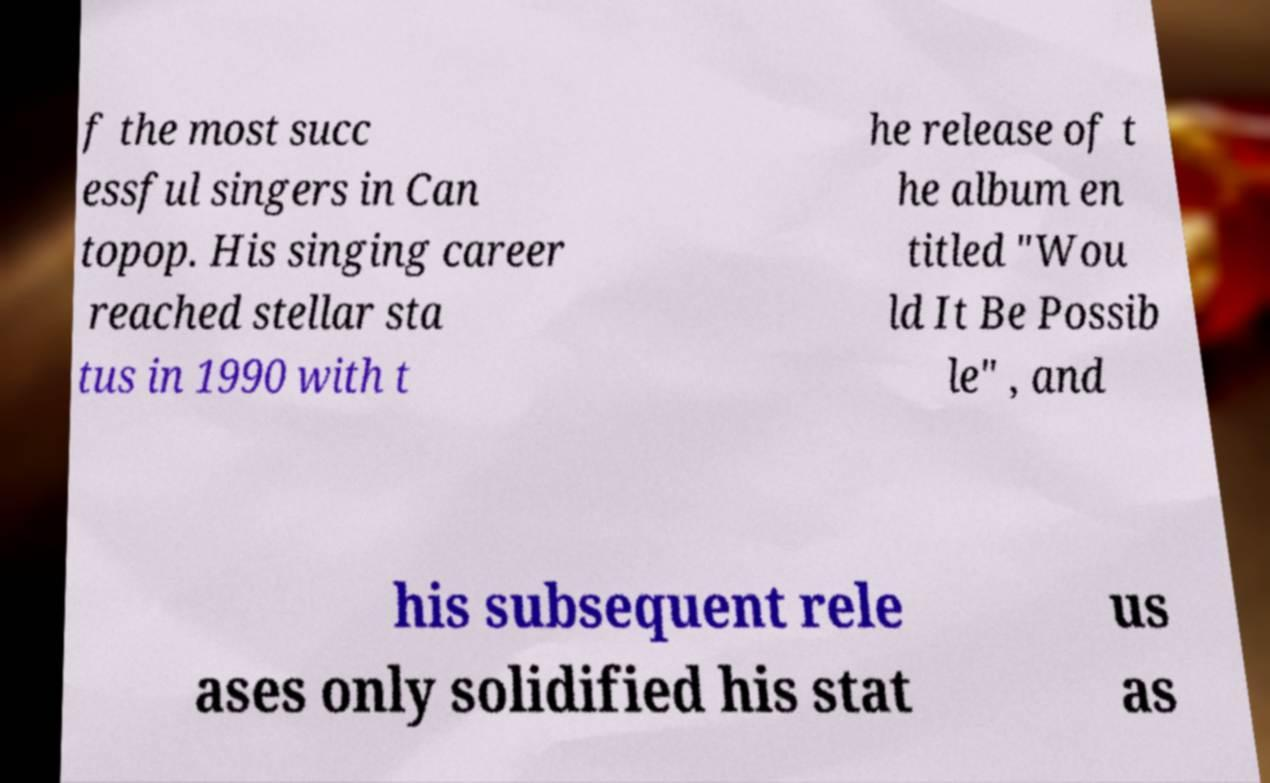Can you accurately transcribe the text from the provided image for me? f the most succ essful singers in Can topop. His singing career reached stellar sta tus in 1990 with t he release of t he album en titled "Wou ld It Be Possib le" , and his subsequent rele ases only solidified his stat us as 